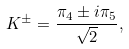Convert formula to latex. <formula><loc_0><loc_0><loc_500><loc_500>K ^ { \pm } = \frac { \pi _ { 4 } \pm i \pi _ { 5 } } { \sqrt { 2 } } ,</formula> 